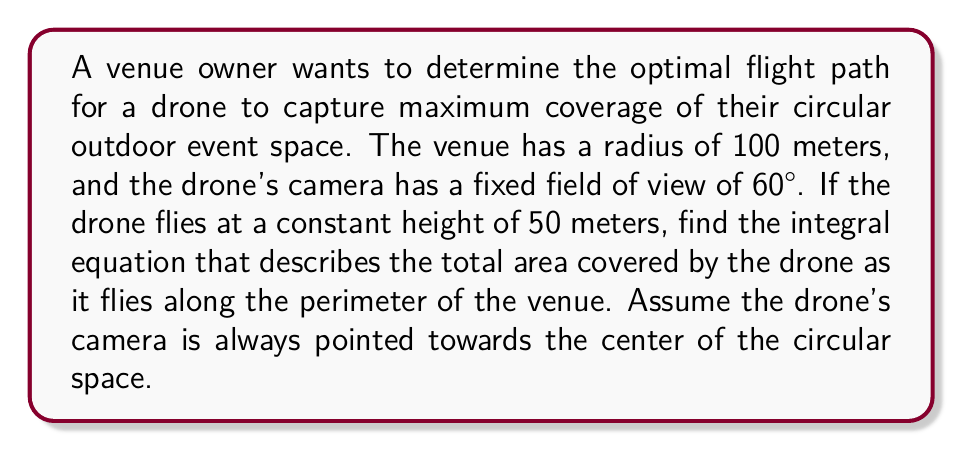Could you help me with this problem? Let's approach this step-by-step:

1) First, we need to determine the radius of the circular area captured by the drone at any given point. Given the drone's height (h) and field of view (θ), we can use trigonometry:

   $r = h \tan(\frac{\theta}{2}) = 50 \tan(30°) \approx 28.87$ meters

2) As the drone moves along the perimeter, it sweeps out a shape similar to a hippopede (a figure-eight curve). The area covered at any instant is the intersection of this circle with the venue.

3) Let's parametrize the drone's position along the perimeter. If the venue's radius is R = 100m, the drone's position at time t can be described as:

   $(x,y) = (R\cos(t), R\sin(t))$, where $0 \leq t \leq 2\pi$

4) The area of intersection between the drone's view circle and the venue circle will depend on the distance between the centers of these circles. This distance is R = 100m.

5) The area of intersection A(R) between two circles of radii r and R, separated by distance R, is given by:

   $$A(R) = 2r^2 \arccos(\frac{R}{2r}) - R\sqrt{r^2 - \frac{R^2}{4}}$$

6) To find the total area covered, we need to integrate this function over the entire path:

   $$\text{Total Area} = \int_0^{2\pi} A(R) dt - \text{Overlap}$$

   The overlap term is necessary because areas near the edge will be covered multiple times.

7) The overlap can be approximated as the area of a circle with radius r: $\pi r^2$

Therefore, the integral equation for the total area covered is:

$$\text{Total Area} = \int_0^{2\pi} [2r^2 \arccos(\frac{R}{2r}) - R\sqrt{r^2 - \frac{R^2}{4}}] dt - \pi r^2$$

Where r ≈ 28.87m and R = 100m.
Answer: $$\int_0^{2\pi} [2(28.87)^2 \arccos(\frac{100}{2(28.87)}) - 100\sqrt{(28.87)^2 - \frac{100^2}{4}}] dt - \pi(28.87)^2$$ 